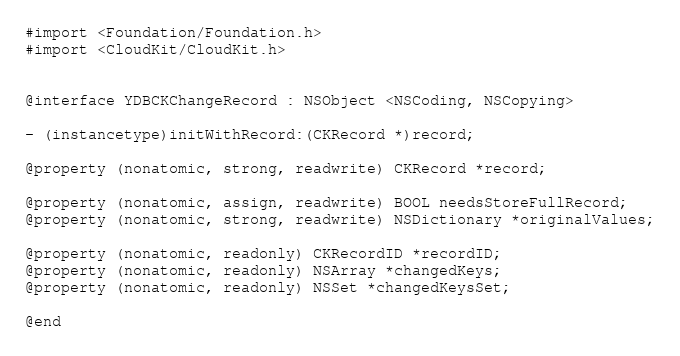<code> <loc_0><loc_0><loc_500><loc_500><_C_>#import <Foundation/Foundation.h>
#import <CloudKit/CloudKit.h>


@interface YDBCKChangeRecord : NSObject <NSCoding, NSCopying>

- (instancetype)initWithRecord:(CKRecord *)record;

@property (nonatomic, strong, readwrite) CKRecord *record;

@property (nonatomic, assign, readwrite) BOOL needsStoreFullRecord;
@property (nonatomic, strong, readwrite) NSDictionary *originalValues;

@property (nonatomic, readonly) CKRecordID *recordID;
@property (nonatomic, readonly) NSArray *changedKeys;
@property (nonatomic, readonly) NSSet *changedKeysSet;

@end
</code> 